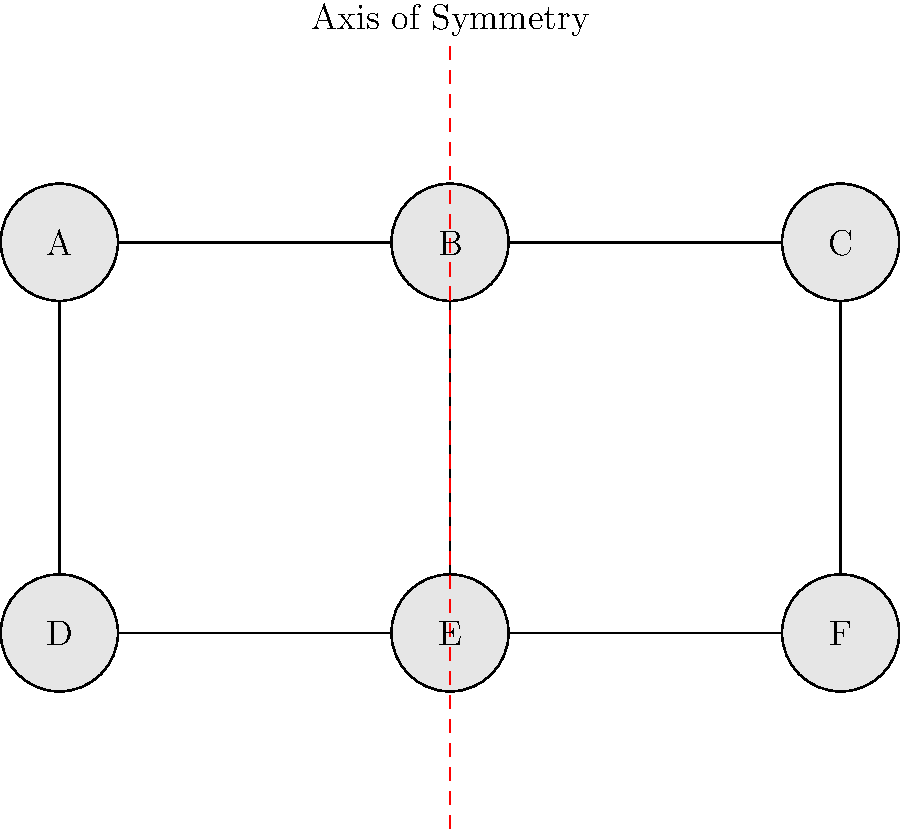In the organizational chart above, companies A, B, and C form the upper tier, while D, E, and F form the lower tier. Identify the type of symmetry present in this chart and determine which transformation would map company A onto company C. To analyze the symmetry and transformations in this organizational chart:

1. Observe the overall structure:
   - The chart has two tiers with three companies in each.
   - There's a vertical line of symmetry passing through company B and E.

2. Identify the type of symmetry:
   - The chart exhibits reflectional symmetry (also called line symmetry or mirror symmetry).
   - If we fold the chart along the red dashed line, the left side would perfectly overlap the right side.

3. Analyze the transformation that would map company A onto company C:
   - A is on the left side of the axis of symmetry, while C is on the right side.
   - The distance from A to the axis is equal to the distance from C to the axis.
   - To transform A onto C, we need to reflect A across the axis of symmetry and then translate it upwards.

4. Determine the specific transformation:
   - The transformation that combines a reflection and a translation is called a glide reflection.
   - In this case, we reflect across the vertical axis and then translate upwards by 0 units (no vertical movement needed).

5. Verify the transformation:
   - Applying this glide reflection to A would indeed map it onto C.
   - The same transformation would map D onto F.

Therefore, the chart exhibits reflectional symmetry, and the transformation mapping A onto C is a glide reflection.
Answer: Reflectional symmetry; Glide reflection 